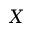Convert formula to latex. <formula><loc_0><loc_0><loc_500><loc_500>X</formula> 